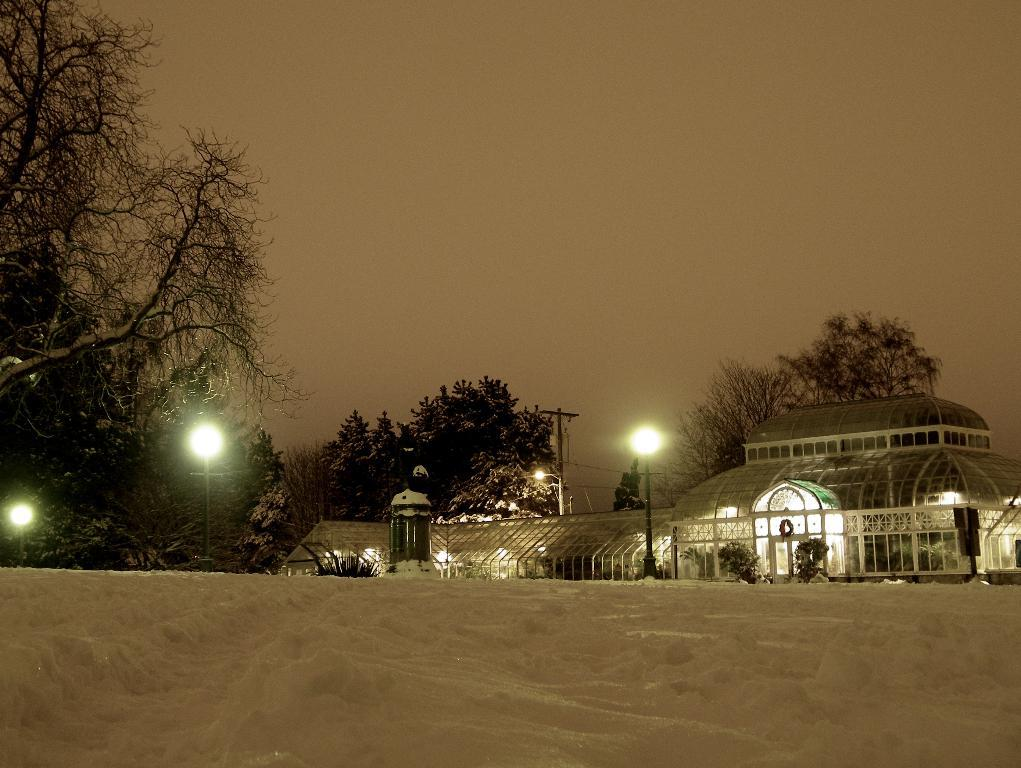What is covering the ground in the image? There is snow on the ground in the image. What can be seen in the background of the image? There is a building with lights in the background. What type of structures are present in the image? There are light poles and an electric pole in the image. What type of natural elements are present in the image? There are trees in the image. What part of the natural environment is visible in the image? The sky is visible in the background of the image. What type of flesh can be seen hanging from the trees in the image? There is no flesh present in the image; it features snow on the ground, a building with lights, light poles, an electric pole, trees, and a visible sky. 